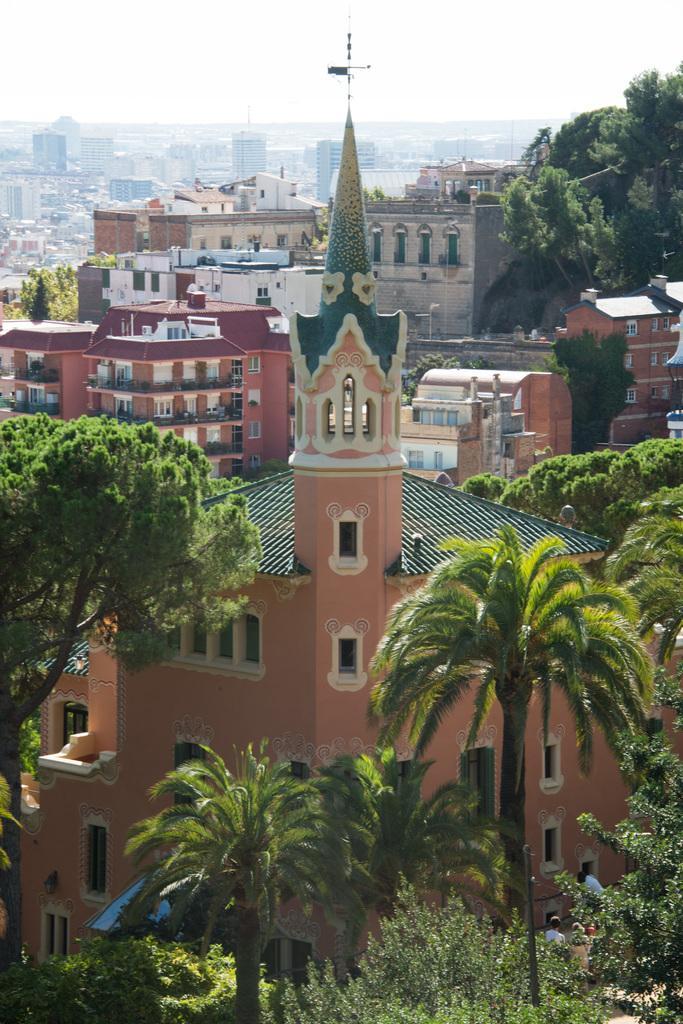How would you summarize this image in a sentence or two? This an aerial view, in this image there are trees, houses, buildings and the sky. 